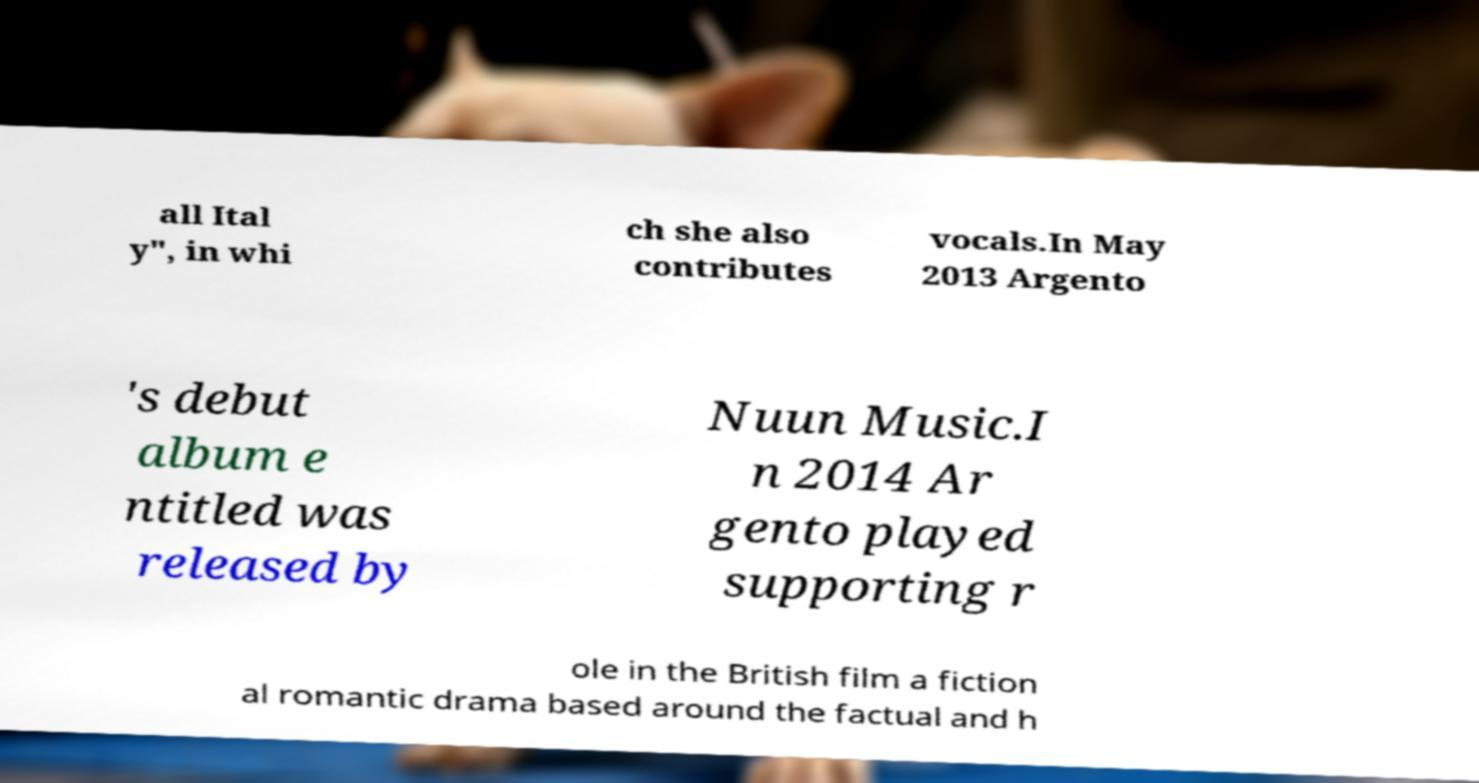Could you extract and type out the text from this image? all Ital y", in whi ch she also contributes vocals.In May 2013 Argento 's debut album e ntitled was released by Nuun Music.I n 2014 Ar gento played supporting r ole in the British film a fiction al romantic drama based around the factual and h 